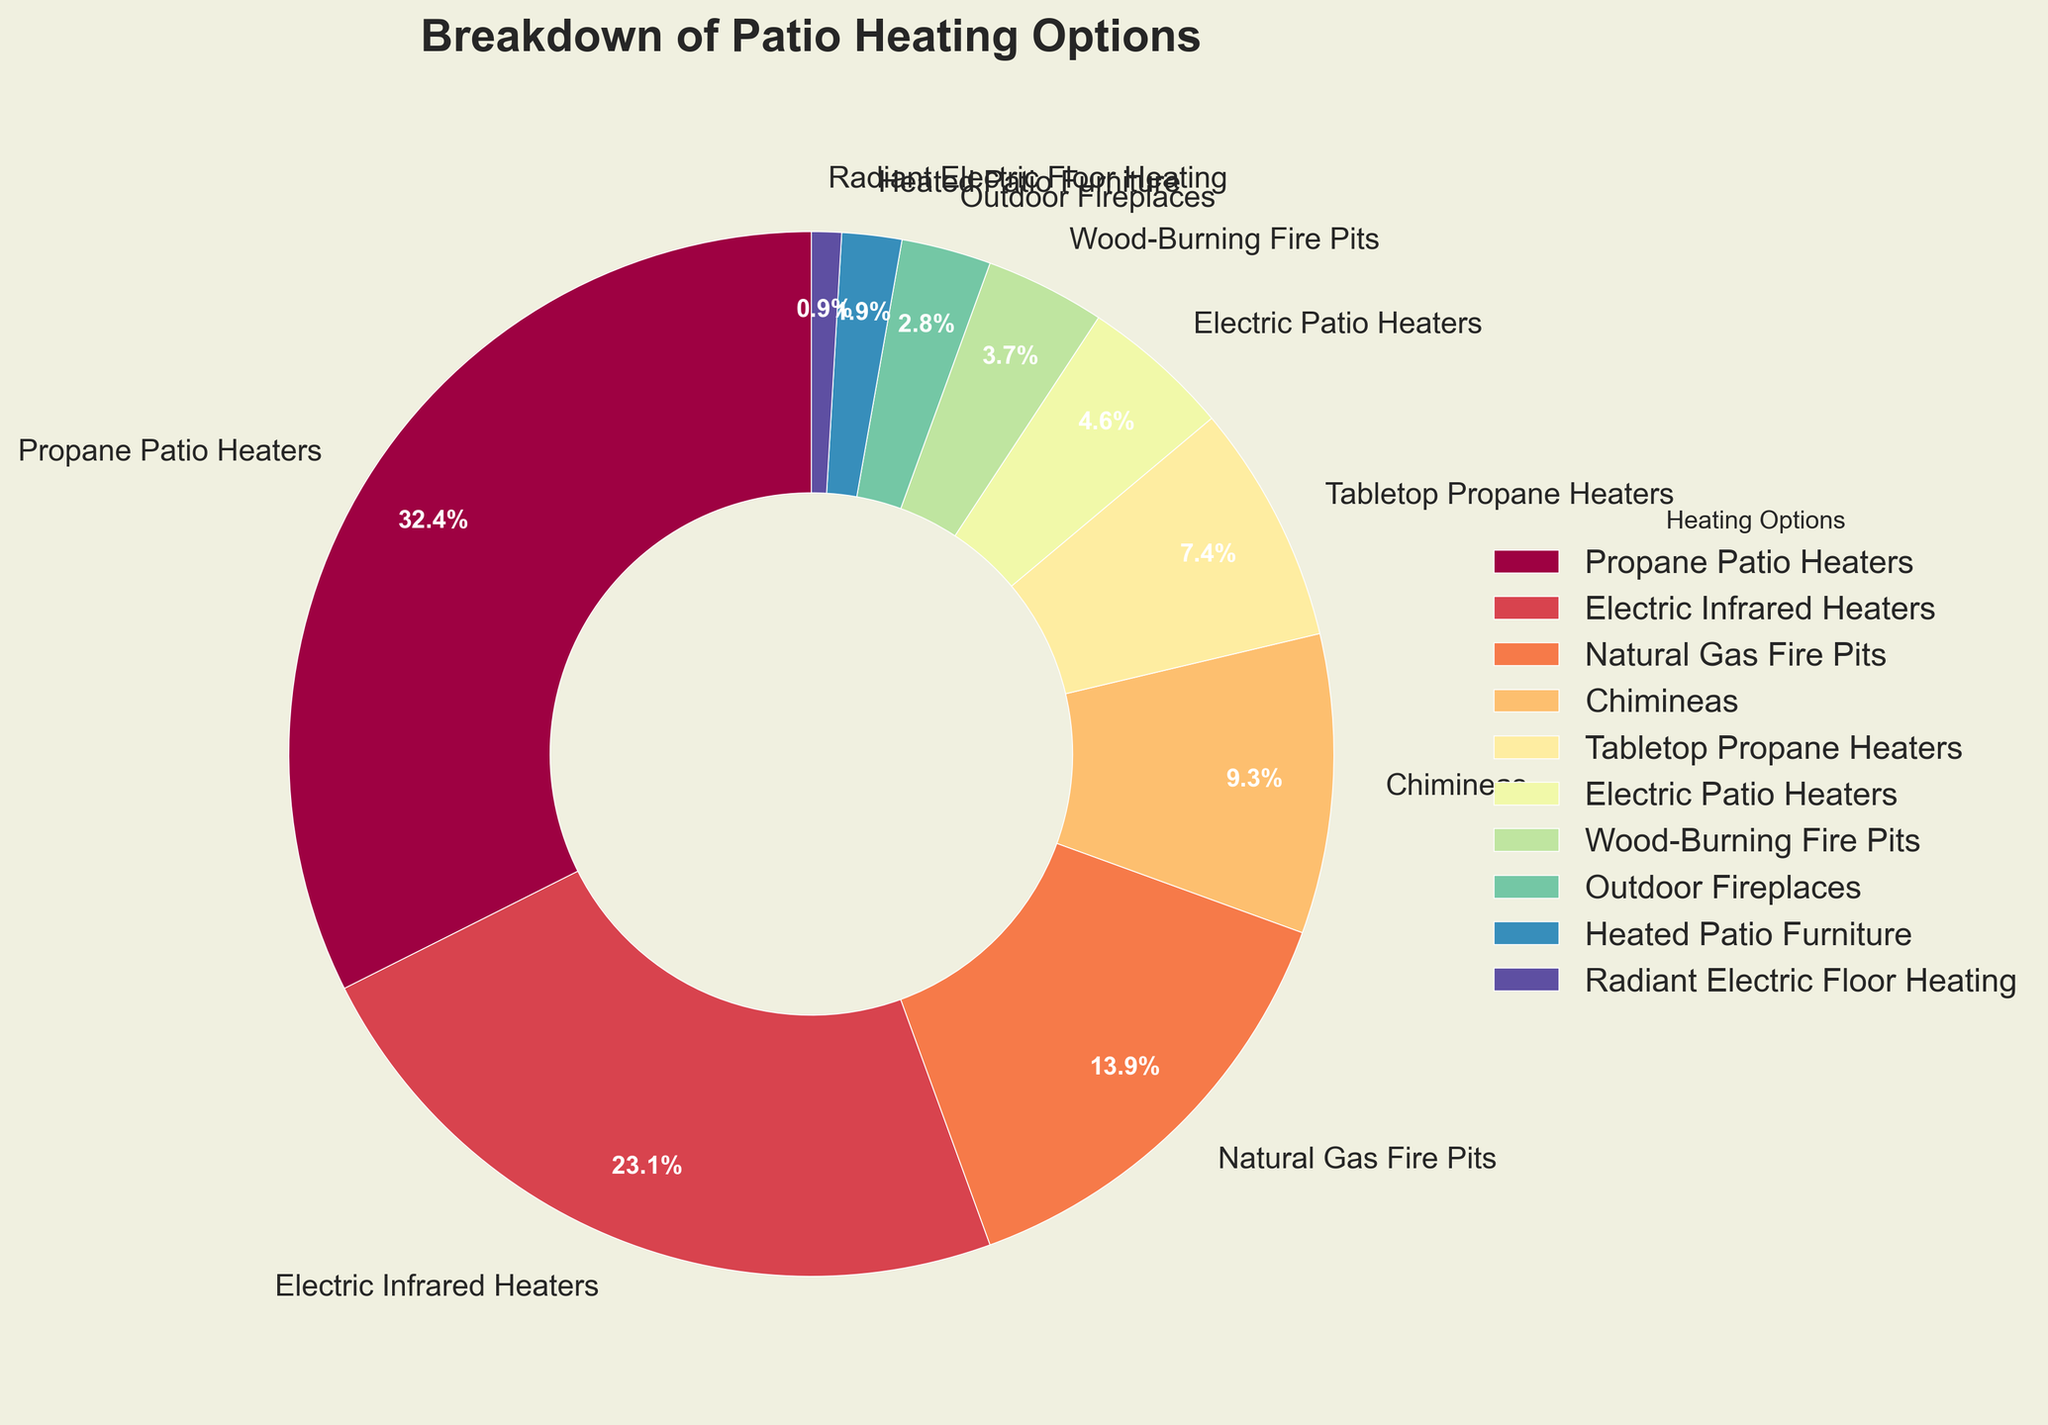What's the most common patio heating option used by outdoor entertainers? The chart shows different patio heating options and their respective percentages. The largest wedge represents the most common option. From the chart, Propane Patio Heaters hold the largest percentage at 35%.
Answer: Propane Patio Heaters What percentage of outdoor entertainers use Electric Infrared Heaters? By looking at the wedge labeled Electric Infrared Heaters on the chart, we see the percentage mentioned next to it. The figure shows that it is 25%.
Answer: 25% What is the combined percentage of outdoor entertainers using Propane Patio Heaters and Natural Gas Fire Pits? We need to add the percentages of the two categories: Propane Patio Heaters (35%) and Natural Gas Fire Pits (15%). This sums up to 50%.
Answer: 50% Are there more people using Chimineas or Electric Infrared Heaters? By comparing the wedges for Chimineas and Electric Infrared Heaters, we see that Electric Infrared Heaters have a larger percentage (25% vs. 10%). Hence, more people use Electric Infrared Heaters.
Answer: Electric Infrared Heaters Which patio heating option is least popular among outdoor entertainers? The smallest wedge on the pie chart represents the least popular option. According to the figure, Radiant Electric Floor Heating is the least popular with 1%.
Answer: Radiant Electric Floor Heating How many patio heating options have a percentage less than 10? By observing the chart, we identify the wedges with percentages less than 10%. These are Tabletop Propane Heaters (8%), Electric Patio Heaters (5%), Wood-Burning Fire Pits (4%), Outdoor Fireplaces (3%), Heated Patio Furniture (2%), and Radiant Electric Floor Heating (1%). Counting these, we find they are 6 in total.
Answer: 6 What's the difference in percentage between the most and least popular patio heating options? Subtract the percentage of the least popular option from the most popular one: Propane Patio Heaters (35%) - Radiant Electric Floor Heating (1%) = 34%.
Answer: 34% What percentage of outdoor entertainers use either Tabletop Propane Heaters or Electric Patio Heaters? Add the percentages of Tabletop Propane Heaters (8%) and Electric Patio Heaters (5%). The total is 13%.
Answer: 13% Are Electric Infrared Heaters more popular than Natural Gas Fire Pits? Comparing the percentages of Electric Infrared Heaters (25%) and Natural Gas Fire Pits (15%), we see that Electric Infrared Heaters are more popular.
Answer: Yes 